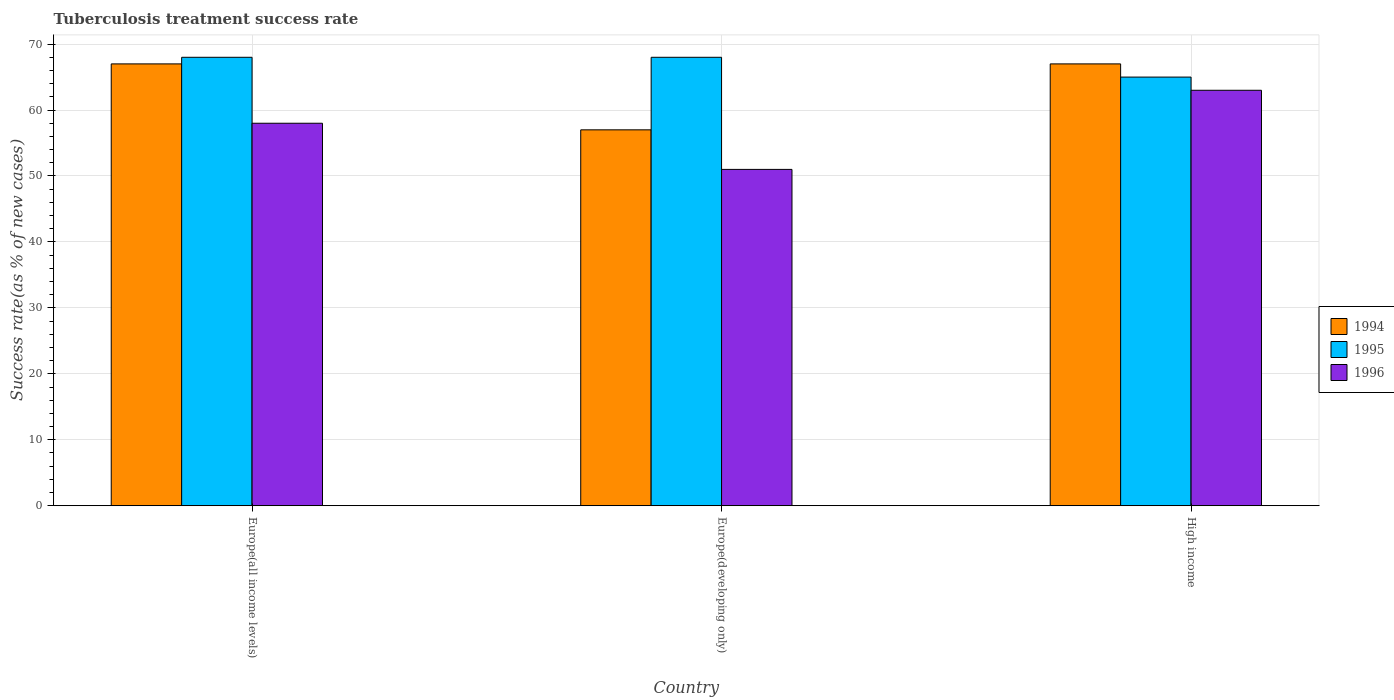How many groups of bars are there?
Make the answer very short. 3. Are the number of bars per tick equal to the number of legend labels?
Ensure brevity in your answer.  Yes. What is the label of the 3rd group of bars from the left?
Make the answer very short. High income. What is the tuberculosis treatment success rate in 1995 in Europe(all income levels)?
Offer a terse response. 68. Across all countries, what is the minimum tuberculosis treatment success rate in 1996?
Your answer should be compact. 51. In which country was the tuberculosis treatment success rate in 1994 maximum?
Your answer should be very brief. Europe(all income levels). What is the total tuberculosis treatment success rate in 1996 in the graph?
Keep it short and to the point. 172. What is the difference between the tuberculosis treatment success rate in 1996 in Europe(developing only) and that in High income?
Ensure brevity in your answer.  -12. What is the difference between the tuberculosis treatment success rate of/in 1996 and tuberculosis treatment success rate of/in 1995 in High income?
Ensure brevity in your answer.  -2. What is the ratio of the tuberculosis treatment success rate in 1994 in Europe(all income levels) to that in Europe(developing only)?
Give a very brief answer. 1.18. Is the tuberculosis treatment success rate in 1996 in Europe(all income levels) less than that in Europe(developing only)?
Your answer should be compact. No. What is the difference between the highest and the lowest tuberculosis treatment success rate in 1996?
Give a very brief answer. 12. In how many countries, is the tuberculosis treatment success rate in 1996 greater than the average tuberculosis treatment success rate in 1996 taken over all countries?
Make the answer very short. 2. Is the sum of the tuberculosis treatment success rate in 1995 in Europe(all income levels) and Europe(developing only) greater than the maximum tuberculosis treatment success rate in 1994 across all countries?
Provide a short and direct response. Yes. What does the 1st bar from the left in High income represents?
Provide a succinct answer. 1994. Are all the bars in the graph horizontal?
Ensure brevity in your answer.  No. How many countries are there in the graph?
Your answer should be compact. 3. What is the difference between two consecutive major ticks on the Y-axis?
Offer a very short reply. 10. Does the graph contain grids?
Your answer should be compact. Yes. How many legend labels are there?
Your answer should be compact. 3. What is the title of the graph?
Your answer should be very brief. Tuberculosis treatment success rate. What is the label or title of the X-axis?
Provide a short and direct response. Country. What is the label or title of the Y-axis?
Offer a very short reply. Success rate(as % of new cases). What is the Success rate(as % of new cases) in 1995 in Europe(all income levels)?
Make the answer very short. 68. What is the Success rate(as % of new cases) in 1994 in Europe(developing only)?
Your answer should be very brief. 57. What is the Success rate(as % of new cases) of 1996 in Europe(developing only)?
Give a very brief answer. 51. What is the Success rate(as % of new cases) of 1996 in High income?
Offer a terse response. 63. Across all countries, what is the maximum Success rate(as % of new cases) of 1996?
Keep it short and to the point. 63. Across all countries, what is the minimum Success rate(as % of new cases) of 1994?
Make the answer very short. 57. Across all countries, what is the minimum Success rate(as % of new cases) in 1996?
Give a very brief answer. 51. What is the total Success rate(as % of new cases) of 1994 in the graph?
Keep it short and to the point. 191. What is the total Success rate(as % of new cases) of 1995 in the graph?
Offer a very short reply. 201. What is the total Success rate(as % of new cases) in 1996 in the graph?
Provide a short and direct response. 172. What is the difference between the Success rate(as % of new cases) in 1995 in Europe(all income levels) and that in High income?
Ensure brevity in your answer.  3. What is the difference between the Success rate(as % of new cases) in 1996 in Europe(all income levels) and that in High income?
Your response must be concise. -5. What is the difference between the Success rate(as % of new cases) of 1996 in Europe(developing only) and that in High income?
Offer a very short reply. -12. What is the difference between the Success rate(as % of new cases) in 1994 in Europe(all income levels) and the Success rate(as % of new cases) in 1995 in Europe(developing only)?
Ensure brevity in your answer.  -1. What is the difference between the Success rate(as % of new cases) of 1994 in Europe(all income levels) and the Success rate(as % of new cases) of 1996 in Europe(developing only)?
Give a very brief answer. 16. What is the difference between the Success rate(as % of new cases) of 1995 in Europe(all income levels) and the Success rate(as % of new cases) of 1996 in Europe(developing only)?
Ensure brevity in your answer.  17. What is the difference between the Success rate(as % of new cases) of 1994 in Europe(developing only) and the Success rate(as % of new cases) of 1996 in High income?
Ensure brevity in your answer.  -6. What is the average Success rate(as % of new cases) of 1994 per country?
Your response must be concise. 63.67. What is the average Success rate(as % of new cases) in 1995 per country?
Provide a short and direct response. 67. What is the average Success rate(as % of new cases) of 1996 per country?
Ensure brevity in your answer.  57.33. What is the difference between the Success rate(as % of new cases) of 1994 and Success rate(as % of new cases) of 1995 in Europe(all income levels)?
Keep it short and to the point. -1. What is the difference between the Success rate(as % of new cases) in 1995 and Success rate(as % of new cases) in 1996 in Europe(all income levels)?
Offer a very short reply. 10. What is the difference between the Success rate(as % of new cases) in 1994 and Success rate(as % of new cases) in 1996 in Europe(developing only)?
Provide a short and direct response. 6. What is the difference between the Success rate(as % of new cases) of 1994 and Success rate(as % of new cases) of 1995 in High income?
Your answer should be compact. 2. What is the difference between the Success rate(as % of new cases) of 1994 and Success rate(as % of new cases) of 1996 in High income?
Your response must be concise. 4. What is the difference between the Success rate(as % of new cases) in 1995 and Success rate(as % of new cases) in 1996 in High income?
Your answer should be compact. 2. What is the ratio of the Success rate(as % of new cases) of 1994 in Europe(all income levels) to that in Europe(developing only)?
Give a very brief answer. 1.18. What is the ratio of the Success rate(as % of new cases) of 1996 in Europe(all income levels) to that in Europe(developing only)?
Your answer should be very brief. 1.14. What is the ratio of the Success rate(as % of new cases) in 1994 in Europe(all income levels) to that in High income?
Offer a very short reply. 1. What is the ratio of the Success rate(as % of new cases) in 1995 in Europe(all income levels) to that in High income?
Offer a terse response. 1.05. What is the ratio of the Success rate(as % of new cases) in 1996 in Europe(all income levels) to that in High income?
Provide a succinct answer. 0.92. What is the ratio of the Success rate(as % of new cases) of 1994 in Europe(developing only) to that in High income?
Your answer should be compact. 0.85. What is the ratio of the Success rate(as % of new cases) of 1995 in Europe(developing only) to that in High income?
Your response must be concise. 1.05. What is the ratio of the Success rate(as % of new cases) of 1996 in Europe(developing only) to that in High income?
Give a very brief answer. 0.81. What is the difference between the highest and the second highest Success rate(as % of new cases) of 1996?
Offer a very short reply. 5. What is the difference between the highest and the lowest Success rate(as % of new cases) of 1994?
Ensure brevity in your answer.  10. What is the difference between the highest and the lowest Success rate(as % of new cases) in 1996?
Your answer should be compact. 12. 